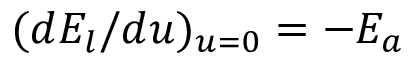<formula> <loc_0><loc_0><loc_500><loc_500>( d E _ { l } / d u ) _ { u = 0 } = - E _ { a }</formula> 